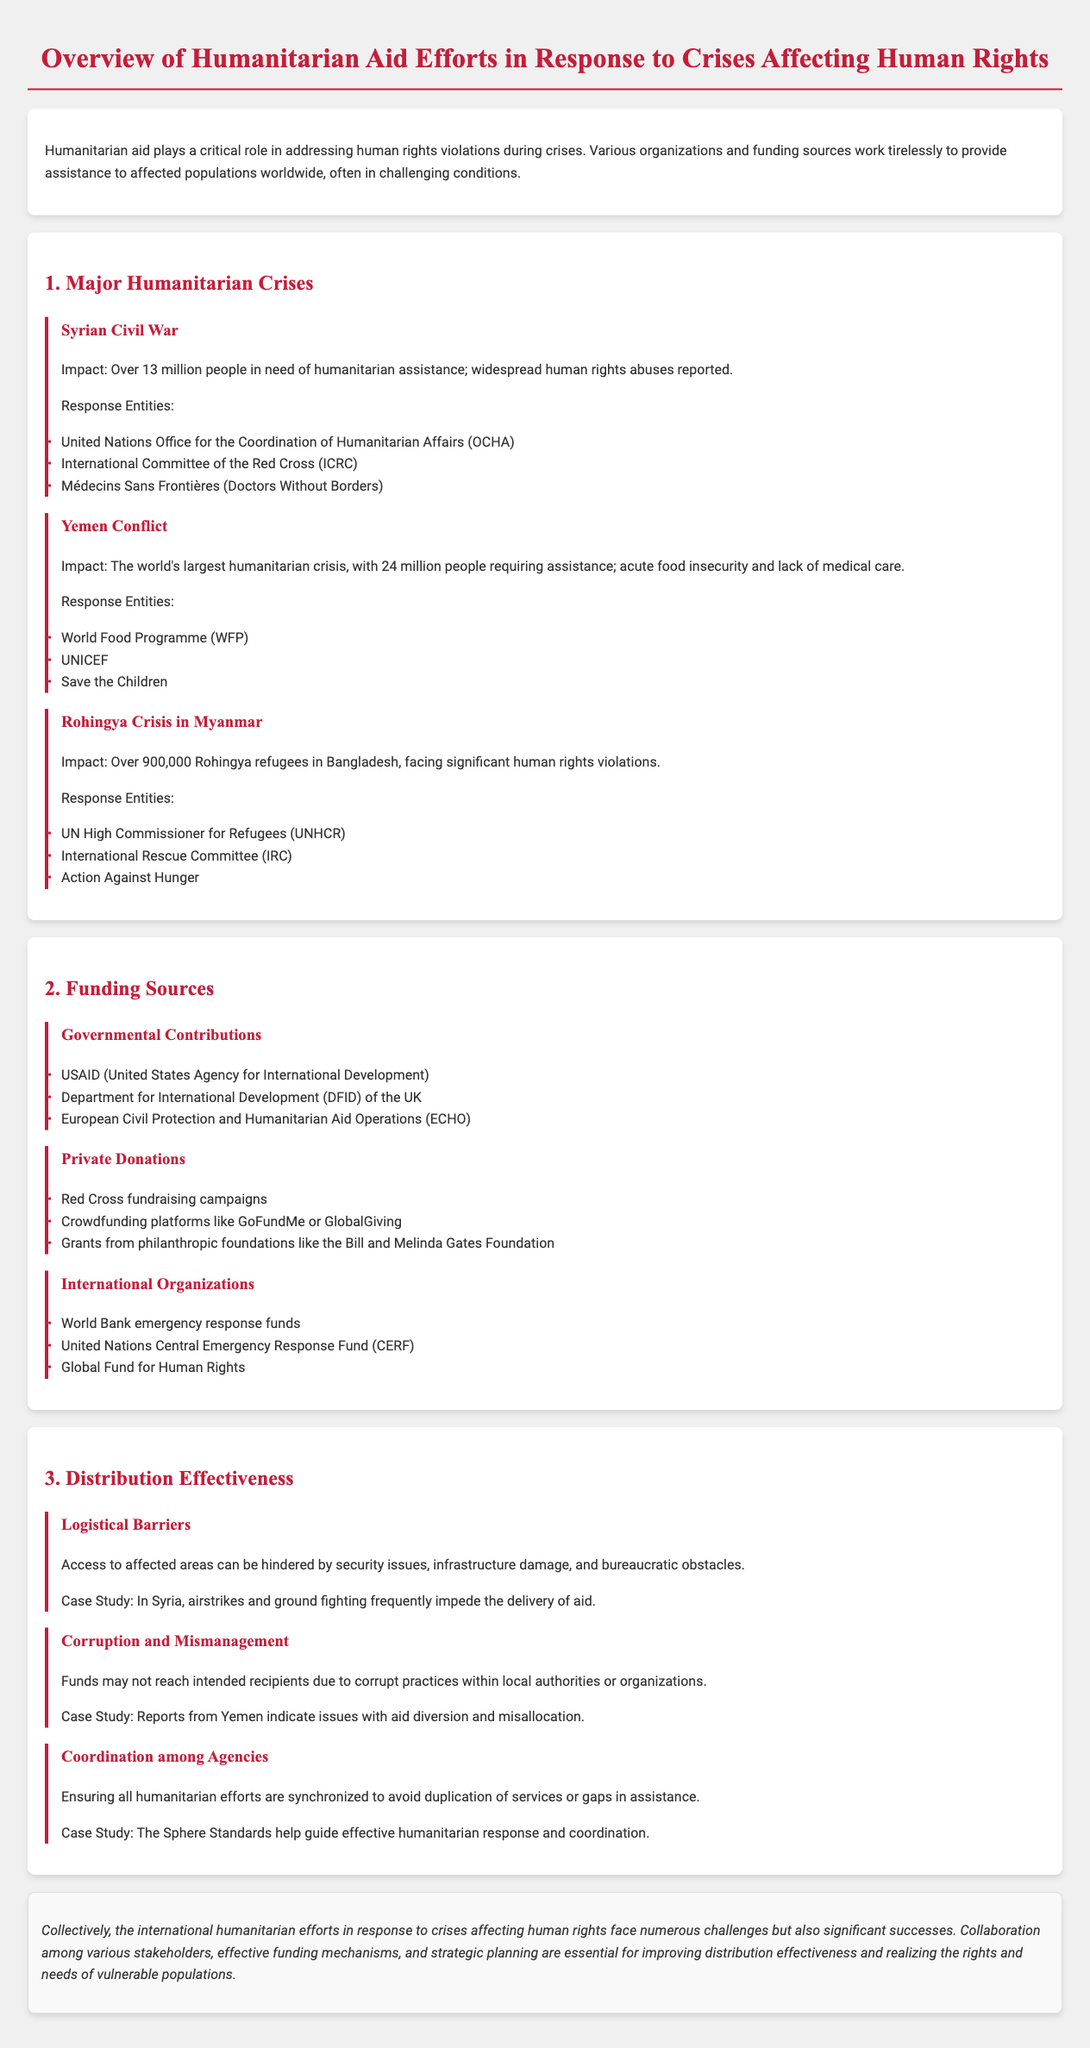What is the impact of the Syrian Civil War on the population? The document states that over 13 million people are in need of humanitarian assistance due to the Syrian Civil War.
Answer: Over 13 million What organization provides aid in Yemen? The document lists the World Food Programme as one of the response entities in Yemen.
Answer: World Food Programme How many Rohingya refugees are in Bangladesh? The document mentions that there are over 900,000 Rohingya refugees in Bangladesh.
Answer: Over 900,000 What is one major funding source for humanitarian aid? The document lists USAID (United States Agency for International Development) as a governmental contribution for funding.
Answer: USAID What are logistical barriers to aid distribution? The document describes security issues, infrastructure damage, and bureaucratic obstacles as logistical barriers.
Answer: Security issues, infrastructure damage, bureaucratic obstacles What case study is mentioned for corruption and mismanagement? The document refers to reports from Yemen indicating issues with aid diversion and misallocation as a case study.
Answer: Reports from Yemen What is a challenge mentioned in the coordination of agencies? The document states that ensuring all humanitarian efforts are synchronized is a challenge in coordination among agencies.
Answer: Synchronization Which organization supports coordination in humanitarian efforts? The document mentions that the Sphere Standards help guide effective humanitarian response and coordination.
Answer: Sphere Standards 